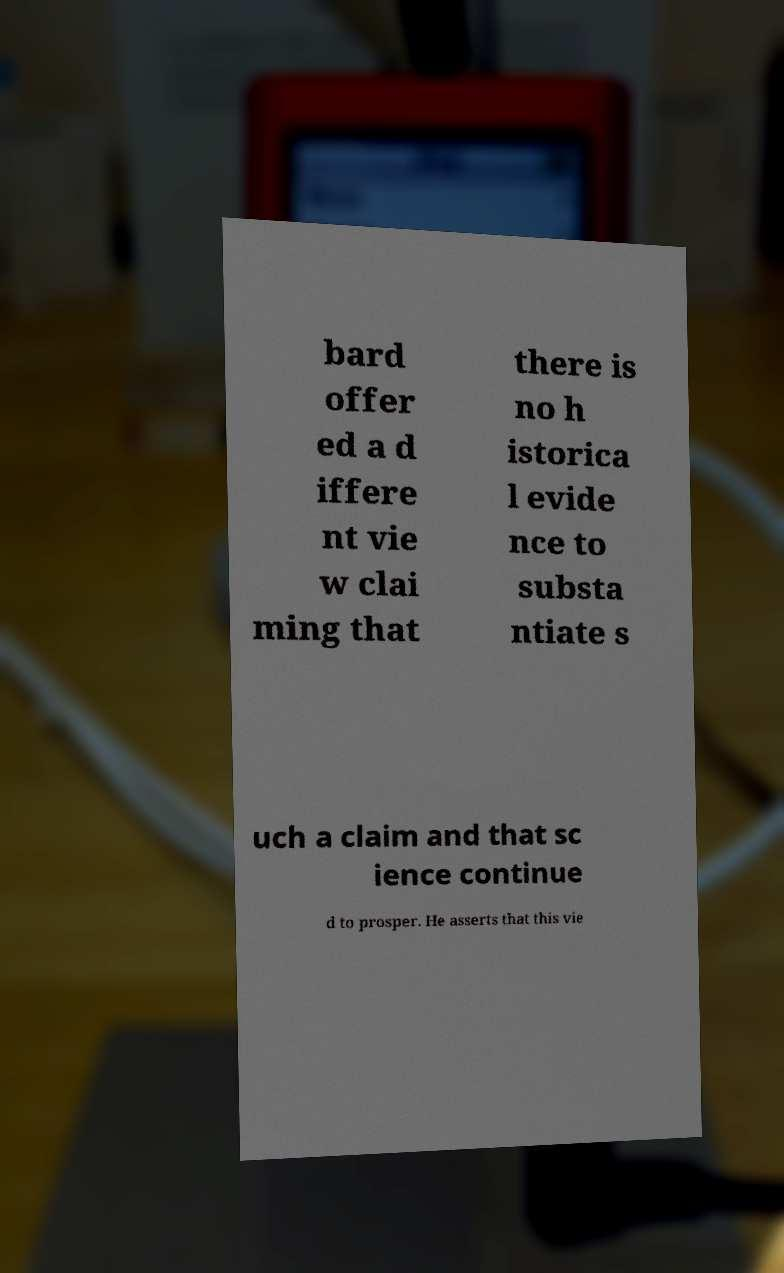Please identify and transcribe the text found in this image. bard offer ed a d iffere nt vie w clai ming that there is no h istorica l evide nce to substa ntiate s uch a claim and that sc ience continue d to prosper. He asserts that this vie 